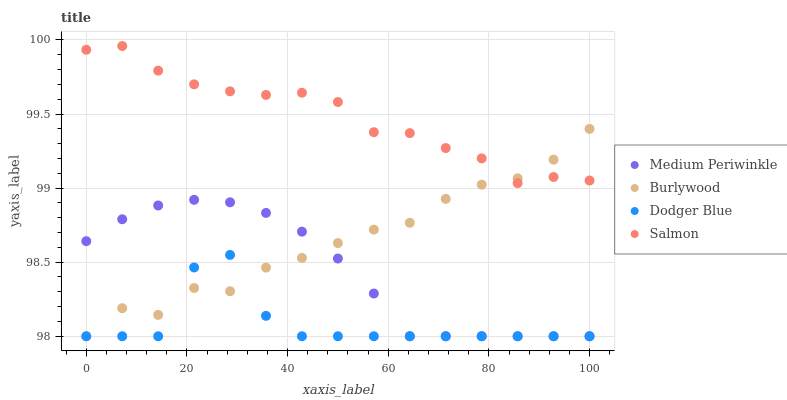Does Dodger Blue have the minimum area under the curve?
Answer yes or no. Yes. Does Salmon have the maximum area under the curve?
Answer yes or no. Yes. Does Medium Periwinkle have the minimum area under the curve?
Answer yes or no. No. Does Medium Periwinkle have the maximum area under the curve?
Answer yes or no. No. Is Medium Periwinkle the smoothest?
Answer yes or no. Yes. Is Dodger Blue the roughest?
Answer yes or no. Yes. Is Dodger Blue the smoothest?
Answer yes or no. No. Is Medium Periwinkle the roughest?
Answer yes or no. No. Does Burlywood have the lowest value?
Answer yes or no. Yes. Does Salmon have the lowest value?
Answer yes or no. No. Does Salmon have the highest value?
Answer yes or no. Yes. Does Medium Periwinkle have the highest value?
Answer yes or no. No. Is Dodger Blue less than Salmon?
Answer yes or no. Yes. Is Salmon greater than Medium Periwinkle?
Answer yes or no. Yes. Does Medium Periwinkle intersect Burlywood?
Answer yes or no. Yes. Is Medium Periwinkle less than Burlywood?
Answer yes or no. No. Is Medium Periwinkle greater than Burlywood?
Answer yes or no. No. Does Dodger Blue intersect Salmon?
Answer yes or no. No. 